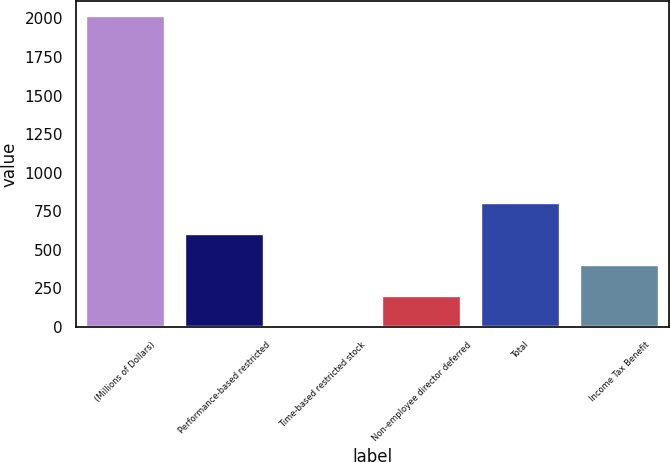Convert chart. <chart><loc_0><loc_0><loc_500><loc_500><bar_chart><fcel>(Millions of Dollars)<fcel>Performance-based restricted<fcel>Time-based restricted stock<fcel>Non-employee director deferred<fcel>Total<fcel>Income Tax Benefit<nl><fcel>2013<fcel>605.3<fcel>2<fcel>203.1<fcel>806.4<fcel>404.2<nl></chart> 